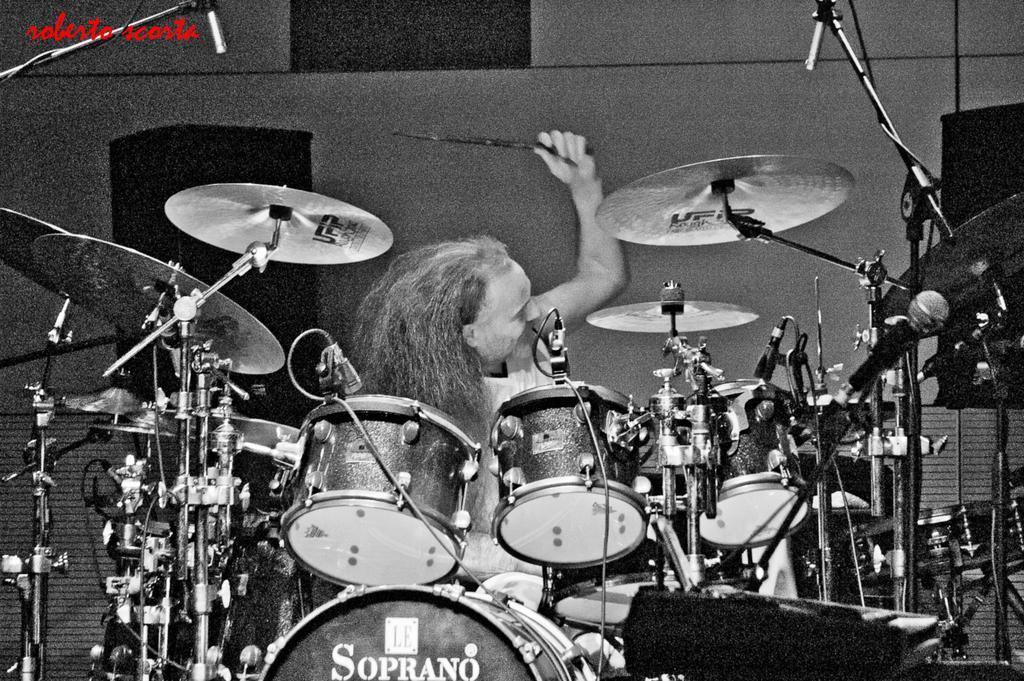Please provide a concise description of this image. This image consists of a person playing drums. In the front, we can see the band setup. He is holding the sticks. In the background, there is a wall. 